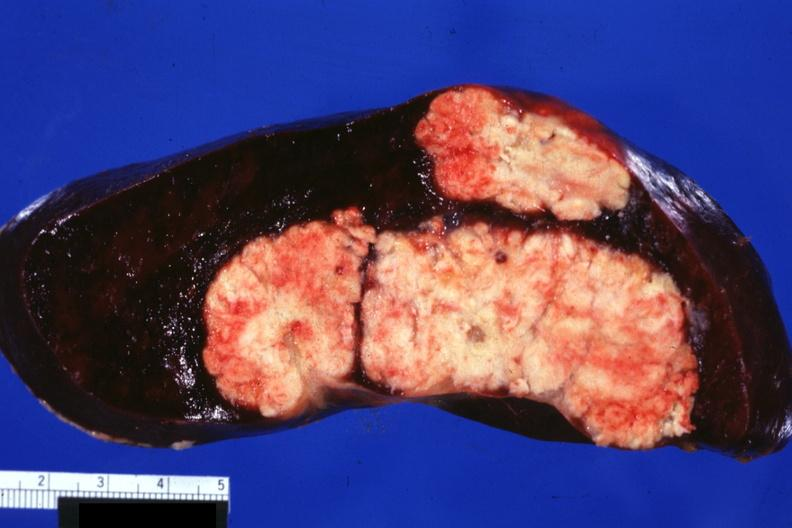s metastatic carcinoma colon present?
Answer the question using a single word or phrase. Yes 